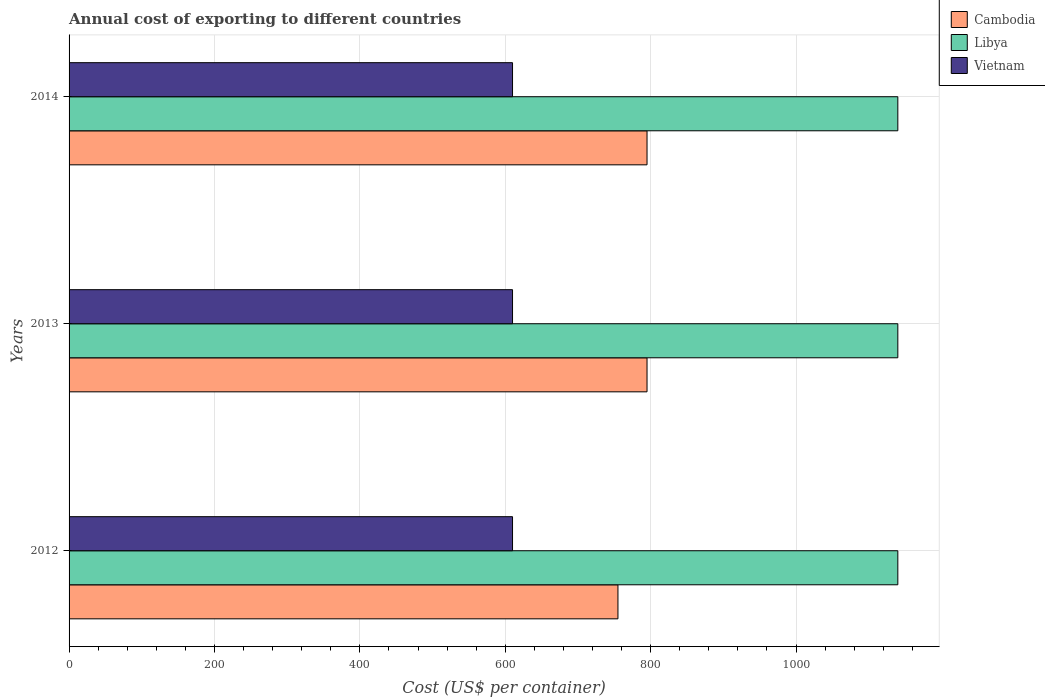How many different coloured bars are there?
Your response must be concise. 3. How many groups of bars are there?
Your answer should be very brief. 3. Are the number of bars per tick equal to the number of legend labels?
Ensure brevity in your answer.  Yes. How many bars are there on the 3rd tick from the top?
Your response must be concise. 3. How many bars are there on the 2nd tick from the bottom?
Provide a succinct answer. 3. What is the label of the 3rd group of bars from the top?
Your response must be concise. 2012. What is the total annual cost of exporting in Libya in 2014?
Offer a very short reply. 1140. Across all years, what is the maximum total annual cost of exporting in Vietnam?
Your answer should be very brief. 610. Across all years, what is the minimum total annual cost of exporting in Vietnam?
Offer a terse response. 610. In which year was the total annual cost of exporting in Libya maximum?
Your response must be concise. 2012. What is the total total annual cost of exporting in Vietnam in the graph?
Give a very brief answer. 1830. What is the difference between the total annual cost of exporting in Cambodia in 2014 and the total annual cost of exporting in Vietnam in 2012?
Make the answer very short. 185. What is the average total annual cost of exporting in Cambodia per year?
Provide a succinct answer. 781.67. In the year 2013, what is the difference between the total annual cost of exporting in Cambodia and total annual cost of exporting in Vietnam?
Keep it short and to the point. 185. What is the ratio of the total annual cost of exporting in Cambodia in 2012 to that in 2014?
Give a very brief answer. 0.95. Is the total annual cost of exporting in Cambodia in 2013 less than that in 2014?
Make the answer very short. No. Is the difference between the total annual cost of exporting in Cambodia in 2012 and 2013 greater than the difference between the total annual cost of exporting in Vietnam in 2012 and 2013?
Give a very brief answer. No. What is the difference between the highest and the lowest total annual cost of exporting in Cambodia?
Give a very brief answer. 40. What does the 2nd bar from the top in 2014 represents?
Provide a succinct answer. Libya. What does the 2nd bar from the bottom in 2012 represents?
Ensure brevity in your answer.  Libya. How many bars are there?
Provide a succinct answer. 9. Are all the bars in the graph horizontal?
Your response must be concise. Yes. What is the difference between two consecutive major ticks on the X-axis?
Ensure brevity in your answer.  200. Are the values on the major ticks of X-axis written in scientific E-notation?
Provide a short and direct response. No. How are the legend labels stacked?
Your answer should be compact. Vertical. What is the title of the graph?
Provide a succinct answer. Annual cost of exporting to different countries. What is the label or title of the X-axis?
Keep it short and to the point. Cost (US$ per container). What is the label or title of the Y-axis?
Offer a very short reply. Years. What is the Cost (US$ per container) in Cambodia in 2012?
Give a very brief answer. 755. What is the Cost (US$ per container) of Libya in 2012?
Your response must be concise. 1140. What is the Cost (US$ per container) of Vietnam in 2012?
Give a very brief answer. 610. What is the Cost (US$ per container) of Cambodia in 2013?
Make the answer very short. 795. What is the Cost (US$ per container) of Libya in 2013?
Provide a succinct answer. 1140. What is the Cost (US$ per container) in Vietnam in 2013?
Ensure brevity in your answer.  610. What is the Cost (US$ per container) in Cambodia in 2014?
Provide a succinct answer. 795. What is the Cost (US$ per container) of Libya in 2014?
Give a very brief answer. 1140. What is the Cost (US$ per container) of Vietnam in 2014?
Provide a short and direct response. 610. Across all years, what is the maximum Cost (US$ per container) in Cambodia?
Provide a succinct answer. 795. Across all years, what is the maximum Cost (US$ per container) of Libya?
Provide a short and direct response. 1140. Across all years, what is the maximum Cost (US$ per container) in Vietnam?
Your answer should be very brief. 610. Across all years, what is the minimum Cost (US$ per container) of Cambodia?
Provide a short and direct response. 755. Across all years, what is the minimum Cost (US$ per container) of Libya?
Offer a very short reply. 1140. Across all years, what is the minimum Cost (US$ per container) of Vietnam?
Your answer should be very brief. 610. What is the total Cost (US$ per container) of Cambodia in the graph?
Give a very brief answer. 2345. What is the total Cost (US$ per container) of Libya in the graph?
Your response must be concise. 3420. What is the total Cost (US$ per container) of Vietnam in the graph?
Provide a succinct answer. 1830. What is the difference between the Cost (US$ per container) in Cambodia in 2012 and that in 2013?
Your answer should be very brief. -40. What is the difference between the Cost (US$ per container) in Libya in 2012 and that in 2013?
Provide a succinct answer. 0. What is the difference between the Cost (US$ per container) of Cambodia in 2012 and that in 2014?
Keep it short and to the point. -40. What is the difference between the Cost (US$ per container) of Libya in 2012 and that in 2014?
Your answer should be compact. 0. What is the difference between the Cost (US$ per container) in Vietnam in 2012 and that in 2014?
Give a very brief answer. 0. What is the difference between the Cost (US$ per container) in Libya in 2013 and that in 2014?
Your response must be concise. 0. What is the difference between the Cost (US$ per container) in Cambodia in 2012 and the Cost (US$ per container) in Libya in 2013?
Make the answer very short. -385. What is the difference between the Cost (US$ per container) in Cambodia in 2012 and the Cost (US$ per container) in Vietnam in 2013?
Provide a succinct answer. 145. What is the difference between the Cost (US$ per container) of Libya in 2012 and the Cost (US$ per container) of Vietnam in 2013?
Give a very brief answer. 530. What is the difference between the Cost (US$ per container) in Cambodia in 2012 and the Cost (US$ per container) in Libya in 2014?
Provide a succinct answer. -385. What is the difference between the Cost (US$ per container) of Cambodia in 2012 and the Cost (US$ per container) of Vietnam in 2014?
Provide a succinct answer. 145. What is the difference between the Cost (US$ per container) of Libya in 2012 and the Cost (US$ per container) of Vietnam in 2014?
Your response must be concise. 530. What is the difference between the Cost (US$ per container) in Cambodia in 2013 and the Cost (US$ per container) in Libya in 2014?
Your response must be concise. -345. What is the difference between the Cost (US$ per container) in Cambodia in 2013 and the Cost (US$ per container) in Vietnam in 2014?
Your response must be concise. 185. What is the difference between the Cost (US$ per container) in Libya in 2013 and the Cost (US$ per container) in Vietnam in 2014?
Give a very brief answer. 530. What is the average Cost (US$ per container) in Cambodia per year?
Make the answer very short. 781.67. What is the average Cost (US$ per container) of Libya per year?
Provide a succinct answer. 1140. What is the average Cost (US$ per container) of Vietnam per year?
Offer a terse response. 610. In the year 2012, what is the difference between the Cost (US$ per container) in Cambodia and Cost (US$ per container) in Libya?
Keep it short and to the point. -385. In the year 2012, what is the difference between the Cost (US$ per container) in Cambodia and Cost (US$ per container) in Vietnam?
Provide a short and direct response. 145. In the year 2012, what is the difference between the Cost (US$ per container) in Libya and Cost (US$ per container) in Vietnam?
Provide a succinct answer. 530. In the year 2013, what is the difference between the Cost (US$ per container) in Cambodia and Cost (US$ per container) in Libya?
Your answer should be very brief. -345. In the year 2013, what is the difference between the Cost (US$ per container) in Cambodia and Cost (US$ per container) in Vietnam?
Your answer should be compact. 185. In the year 2013, what is the difference between the Cost (US$ per container) of Libya and Cost (US$ per container) of Vietnam?
Offer a terse response. 530. In the year 2014, what is the difference between the Cost (US$ per container) of Cambodia and Cost (US$ per container) of Libya?
Offer a terse response. -345. In the year 2014, what is the difference between the Cost (US$ per container) in Cambodia and Cost (US$ per container) in Vietnam?
Your response must be concise. 185. In the year 2014, what is the difference between the Cost (US$ per container) in Libya and Cost (US$ per container) in Vietnam?
Keep it short and to the point. 530. What is the ratio of the Cost (US$ per container) in Cambodia in 2012 to that in 2013?
Give a very brief answer. 0.95. What is the ratio of the Cost (US$ per container) of Libya in 2012 to that in 2013?
Ensure brevity in your answer.  1. What is the ratio of the Cost (US$ per container) in Vietnam in 2012 to that in 2013?
Your answer should be compact. 1. What is the ratio of the Cost (US$ per container) in Cambodia in 2012 to that in 2014?
Your answer should be compact. 0.95. What is the ratio of the Cost (US$ per container) in Libya in 2012 to that in 2014?
Your answer should be compact. 1. What is the ratio of the Cost (US$ per container) of Vietnam in 2012 to that in 2014?
Provide a succinct answer. 1. What is the ratio of the Cost (US$ per container) of Cambodia in 2013 to that in 2014?
Give a very brief answer. 1. What is the ratio of the Cost (US$ per container) of Libya in 2013 to that in 2014?
Your answer should be compact. 1. What is the difference between the highest and the second highest Cost (US$ per container) of Cambodia?
Provide a succinct answer. 0. What is the difference between the highest and the second highest Cost (US$ per container) of Vietnam?
Offer a very short reply. 0. What is the difference between the highest and the lowest Cost (US$ per container) in Libya?
Offer a terse response. 0. What is the difference between the highest and the lowest Cost (US$ per container) in Vietnam?
Your response must be concise. 0. 